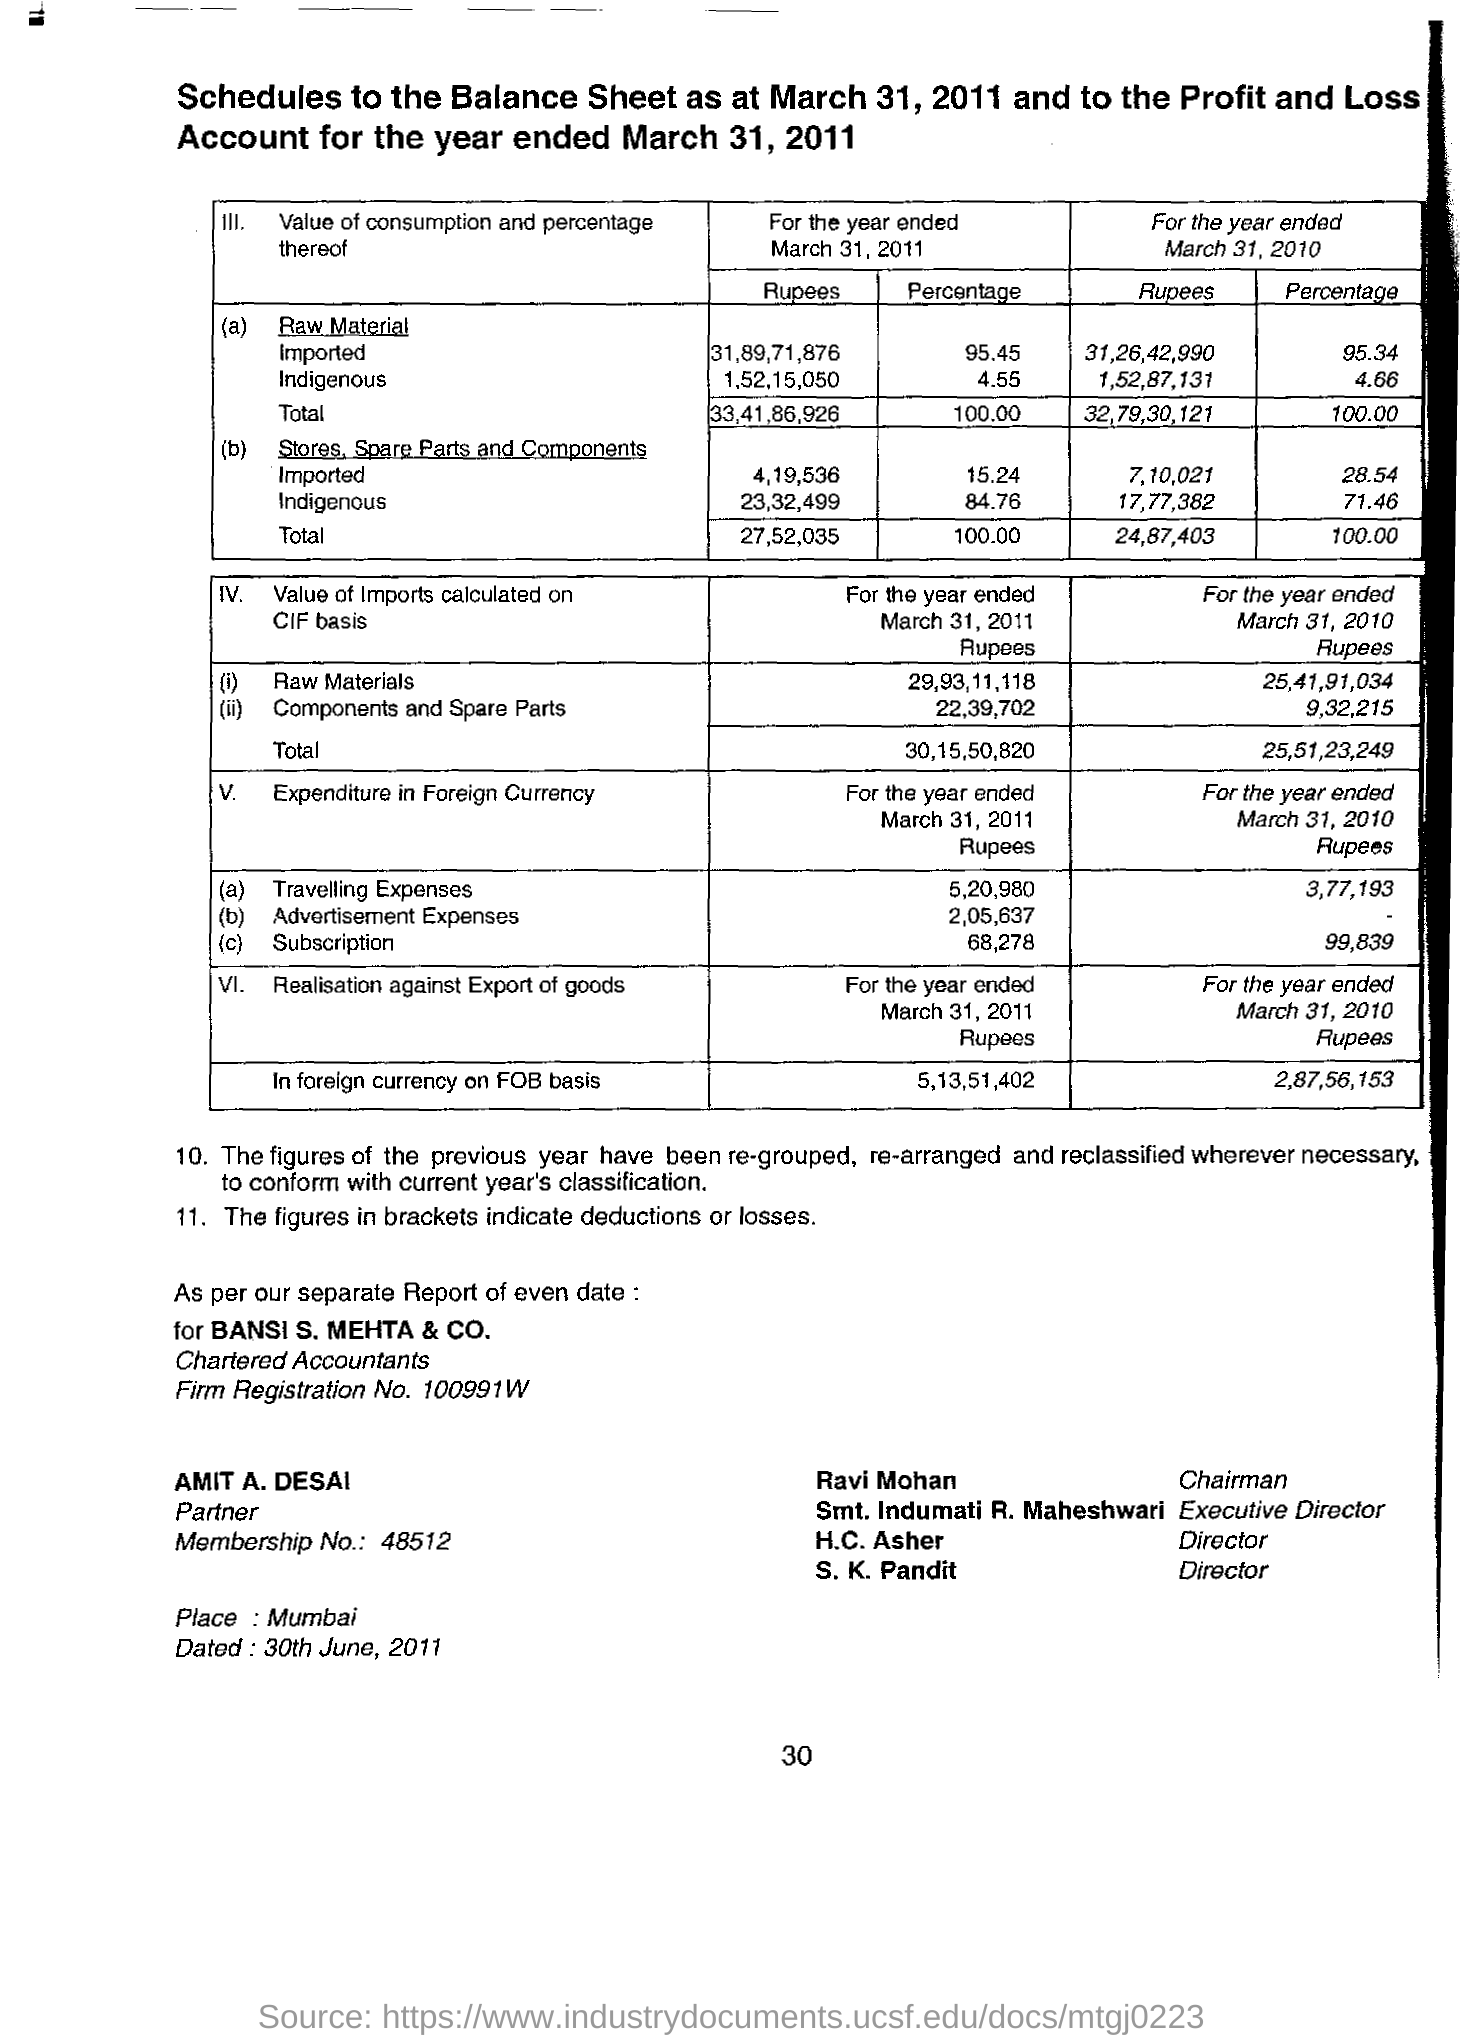When is the document dated on?
Your response must be concise. 30th June,2011. What is the place name on the document?
Offer a terse response. Mumbai. Who is the Chairman?
Offer a very short reply. Ravi Mohan. What is the Membership No.?
Provide a short and direct response. 48512. 